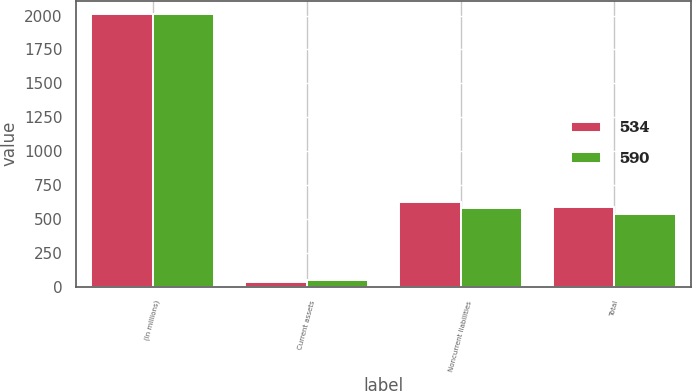Convert chart to OTSL. <chart><loc_0><loc_0><loc_500><loc_500><stacked_bar_chart><ecel><fcel>(In millions)<fcel>Current assets<fcel>Noncurrent liabilities<fcel>Total<nl><fcel>534<fcel>2010<fcel>37<fcel>627<fcel>590<nl><fcel>590<fcel>2009<fcel>46<fcel>580<fcel>534<nl></chart> 